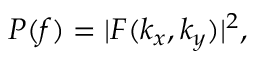<formula> <loc_0><loc_0><loc_500><loc_500>P ( f ) = | F ( k _ { x } , k _ { y } ) | ^ { 2 } ,</formula> 